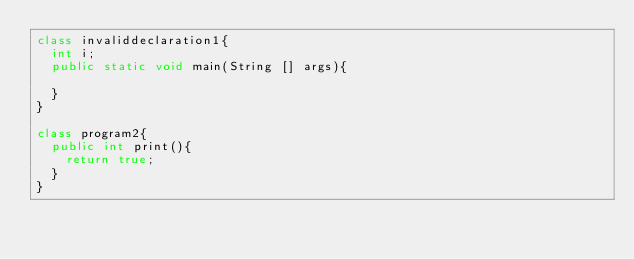<code> <loc_0><loc_0><loc_500><loc_500><_Java_>class invaliddeclaration1{
	int i;
	public static void main(String [] args){
		
	}
}

class program2{
	public int print(){
		return true;
	}
}</code> 